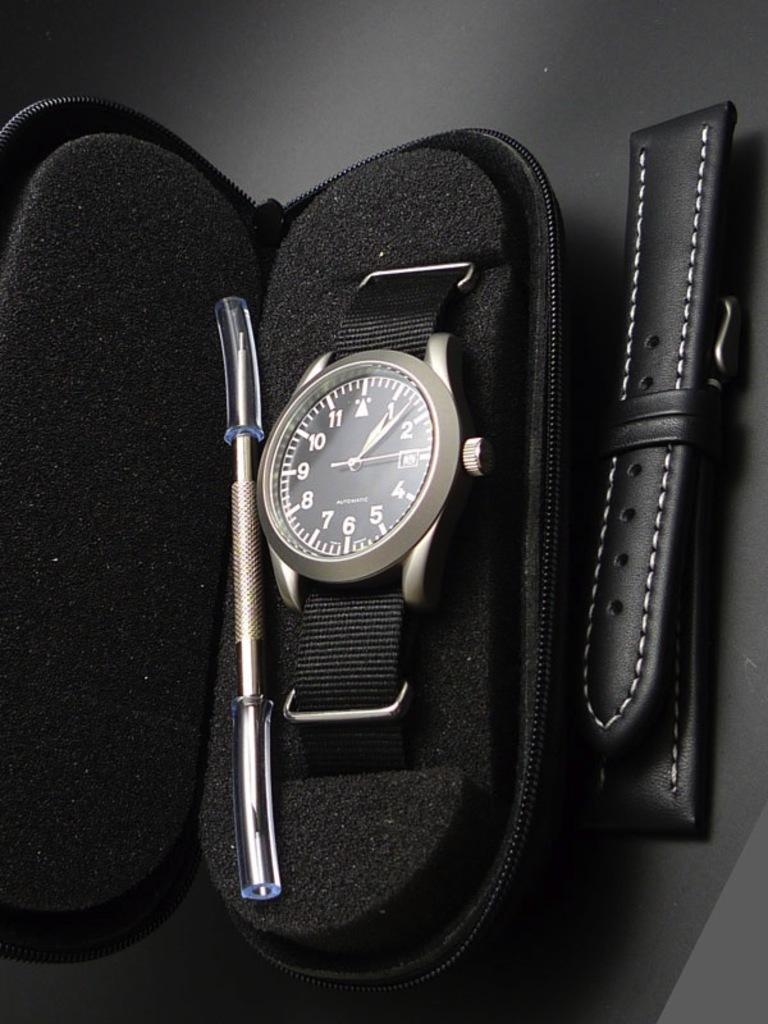<image>
Describe the image concisely. A watch is in a case and it shows a time of 1:08. 